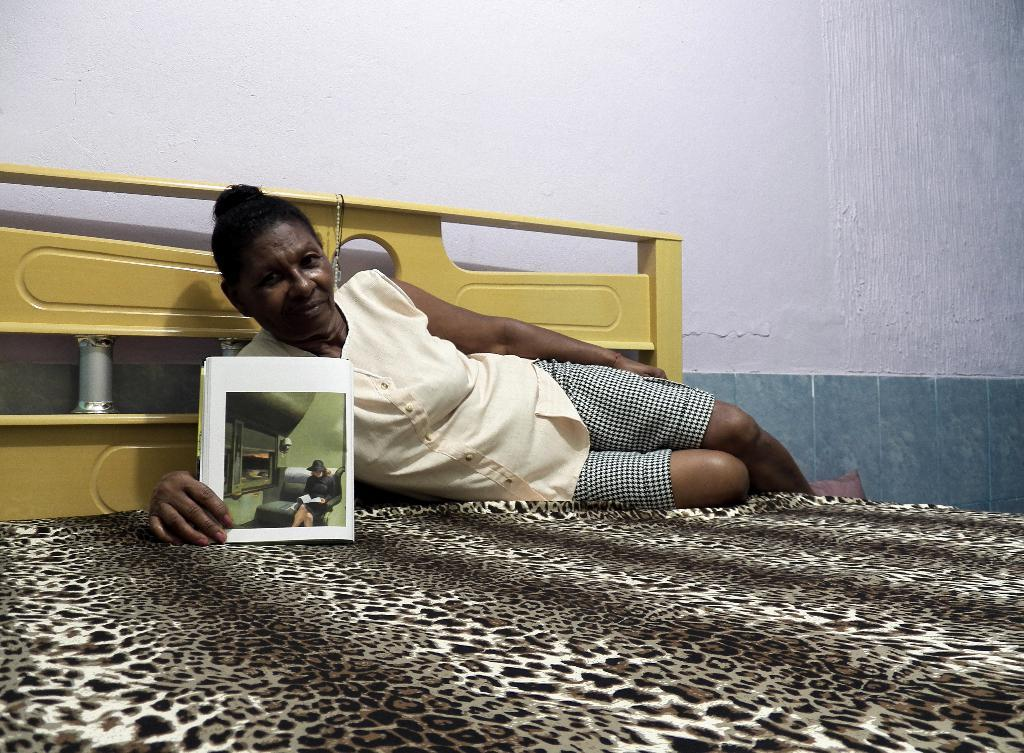Who is the main subject in the image? There is a woman in the image. What is the woman doing in the image? The woman is on a bed. What can be seen in the background of the image? There is a wall in the background of the image. What invention is the woman holding in the image? There is no invention visible in the image; the woman is simply lying on a bed. 